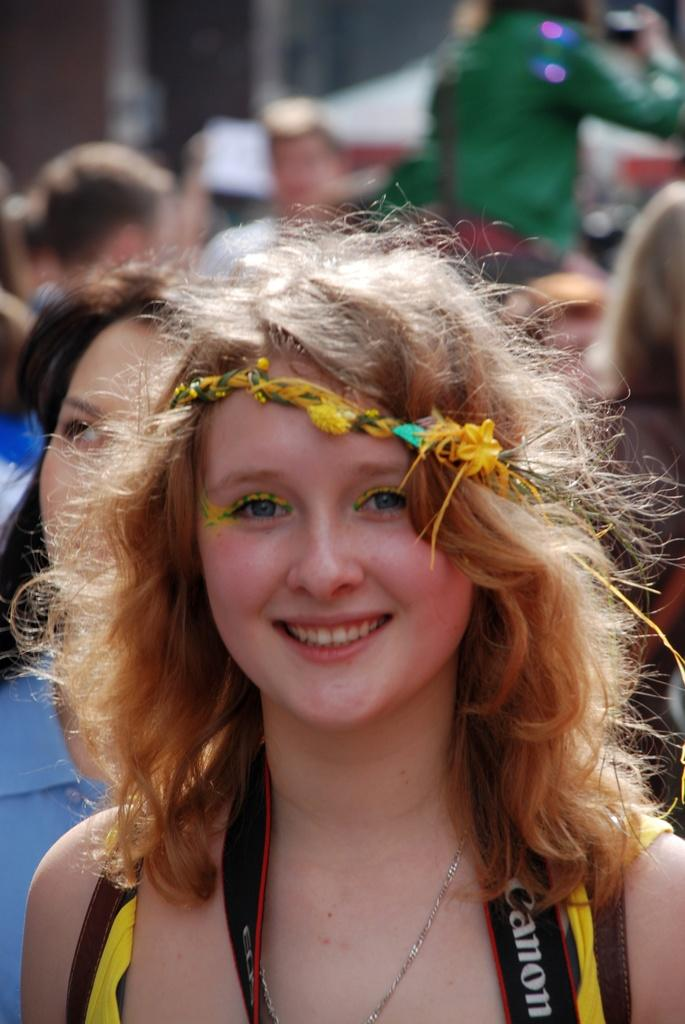Who is the main subject in the image? There is a woman in the image. What is the woman wearing on her head? The woman is wearing a crown. What is the woman's facial expression in the image? The woman is smiling. Can you describe the people visible in the background of the image? There are persons visible in the background of the image, but their specific characteristics are not mentioned in the provided facts. What does the woman's stomach feel like in the image? The provided facts do not mention anything about the woman's stomach, so it cannot be determined from the image. 